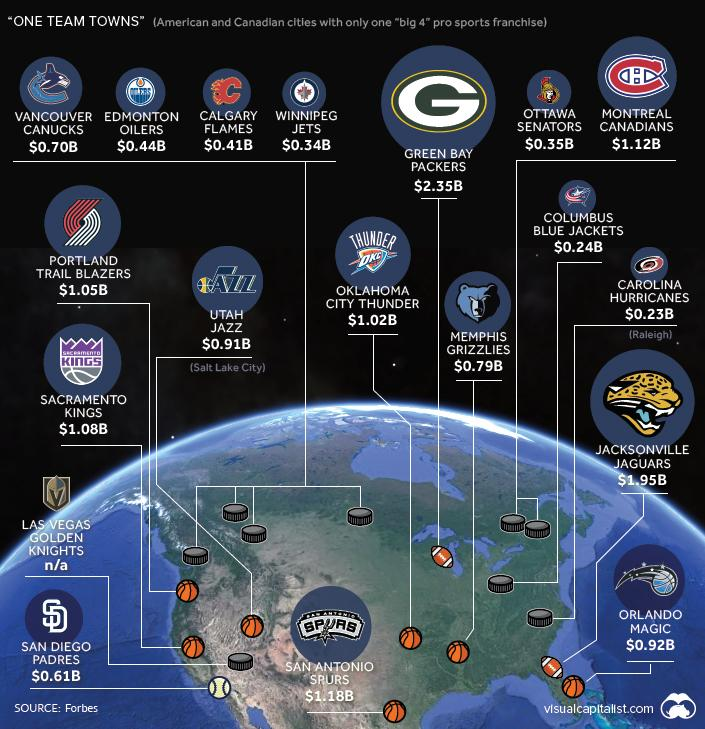Point out several critical features in this image. The written text inside the logo of the Oklahoma City Thunder is "Thunder DKC". The total value of the Portland Trail Blazers and Utah Jazz basketball teams is approximately 1.96 billion US dollars. The value of the Columbus Blue Jackets is estimated to be approximately $0.24 billion. 